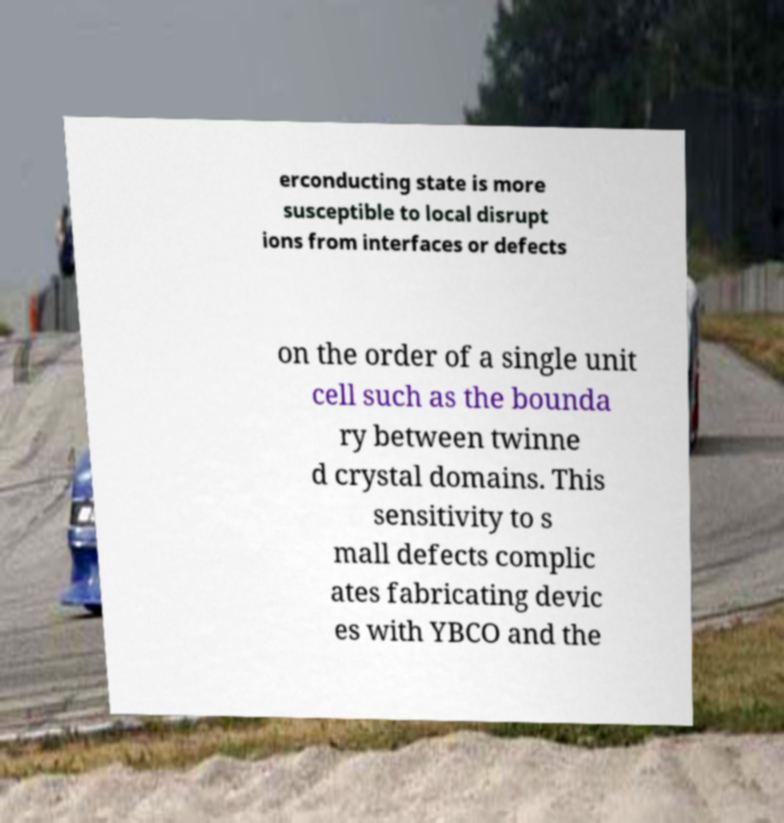Can you accurately transcribe the text from the provided image for me? erconducting state is more susceptible to local disrupt ions from interfaces or defects on the order of a single unit cell such as the bounda ry between twinne d crystal domains. This sensitivity to s mall defects complic ates fabricating devic es with YBCO and the 